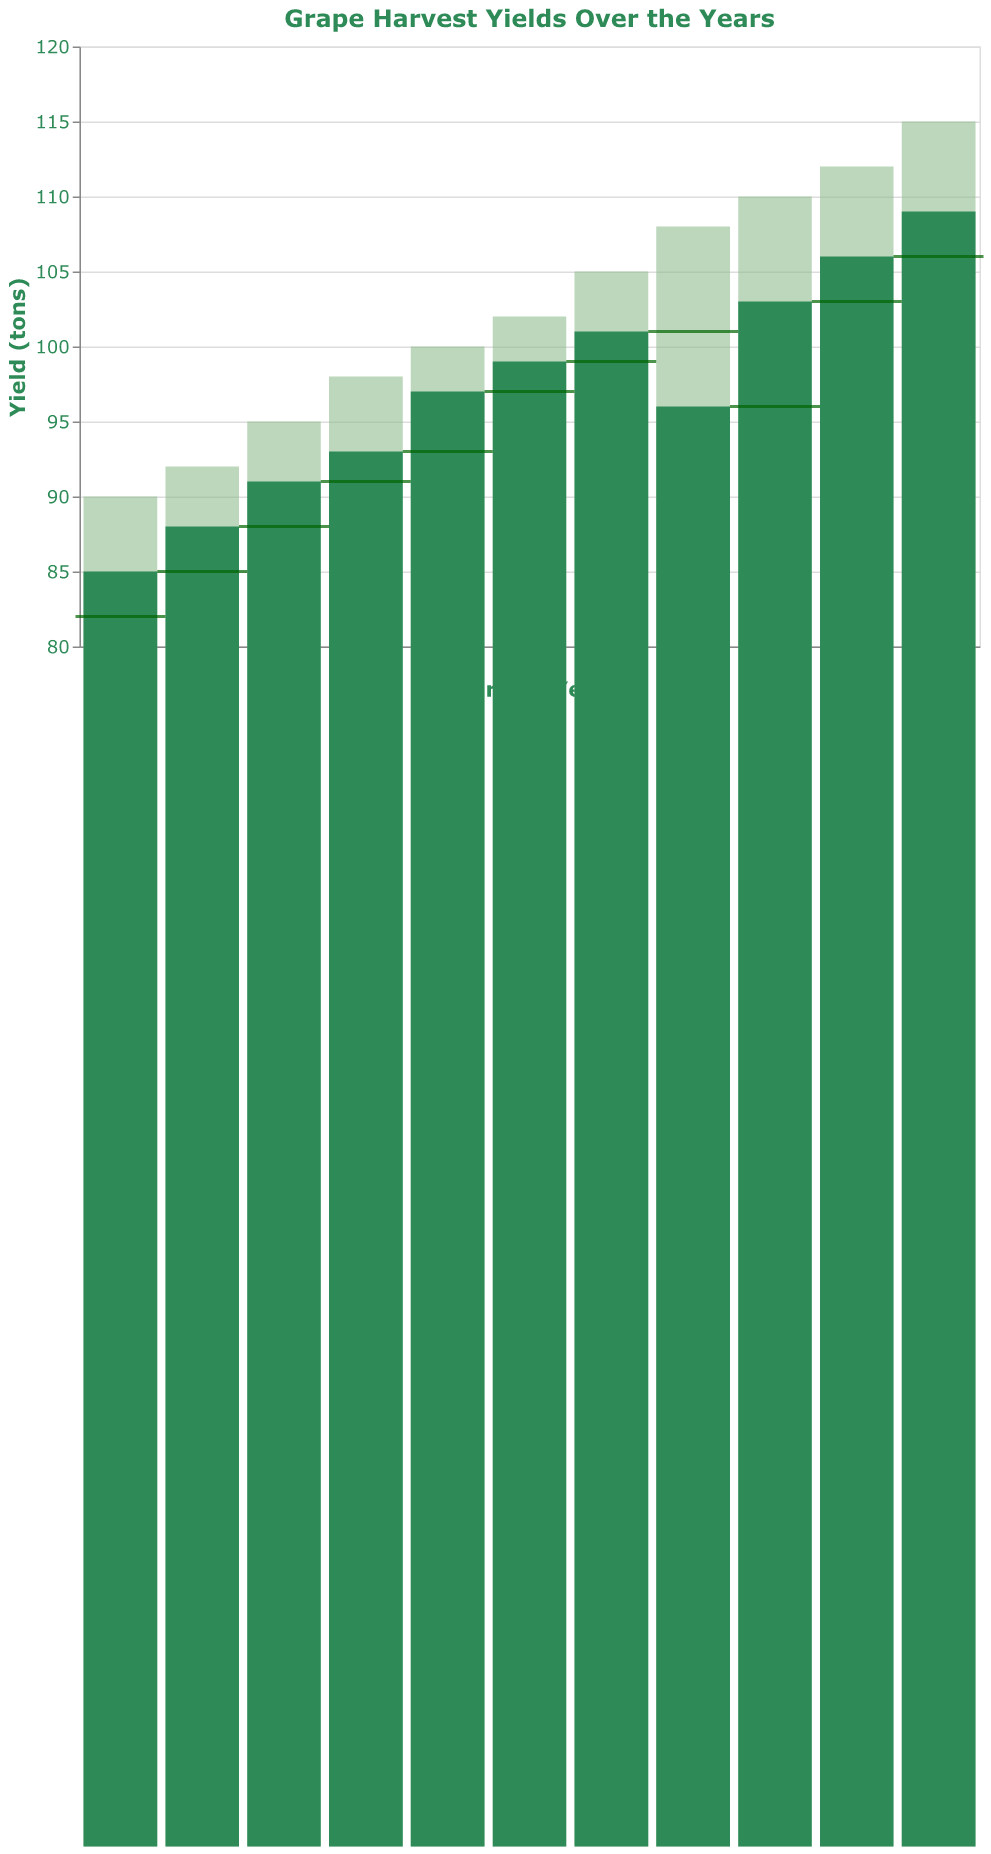What is the title of the chart? The title is often found at the top of the chart, and it summarizes the main content or purpose of the chart. Here, it is "Grape Harvest Yields Over the Years".
Answer: Grape Harvest Yields Over the Years What is the actual yield in 2020? To find the actual yield in 2020, look for the bar corresponding to the year 2020 and read its height, which represents the actual yield.
Answer: 96 tons Which year had the highest actual yield? Look for the tallest bar among the bars colored in #2E8B57 (a shade of green), which represents the actual yield. The tallest bar corresponds to the year 2023.
Answer: 2023 What is the difference between the target yield and actual yield in 2023? To find the difference, subtract the actual yield from the target yield for the year 2023. The target yield is 115 tons and the actual yield is 109 tons.
Answer: 6 tons How does the actual yield of 2020 compare to the previous year's yield? The actual yield of 2020 is 96 tons, indicated by the bar, and the previous year's yield (2019) is represented by the tick mark, which is 101 tons. Compare these two values.
Answer: Lower What trend can you observe in the target yields from 2013 to 2023? The target yields should be assessed year-by-year to see if they generally increase, decrease, or stay the same. From 2013 to 2023, the target yields show an increasing trend.
Answer: Increasing trend Which year had a significant drop in actual yield compared to the target yield? Compare the actual yield and target yield for each year to identify where there's a noticeable drop. In 2020, the actual yield (96 tons) was significantly lower than the target yield (108 tons).
Answer: 2020 How did the actual yield in 2019 compare to 2018? Look at the heights of the bars for 2019 and 2018. The actual yield for 2019 (101 tons) is higher than the actual yield for 2018 (99 tons).
Answer: Higher What is the total target yield from 2013 to 2023? Add all the target yields from each year from 2013 to 2023: 90+92+95+98+100+102+105+108+110+112+115 = 1127 tons.
Answer: 1127 tons What is the average actual yield over the decade from 2013 to 2023? Sum the actual yields and divide by the number of years: (85+88+91+93+97+99+101+96+103+106+109) / 11 = 969 / 11 ≈ 88.1 tons
Answer: 88.1 tons 